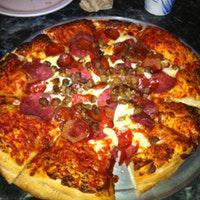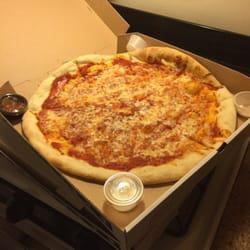The first image is the image on the left, the second image is the image on the right. For the images displayed, is the sentence "One image shows a pizza in an open box and includes at least two condiment containers in the image." factually correct? Answer yes or no. Yes. 